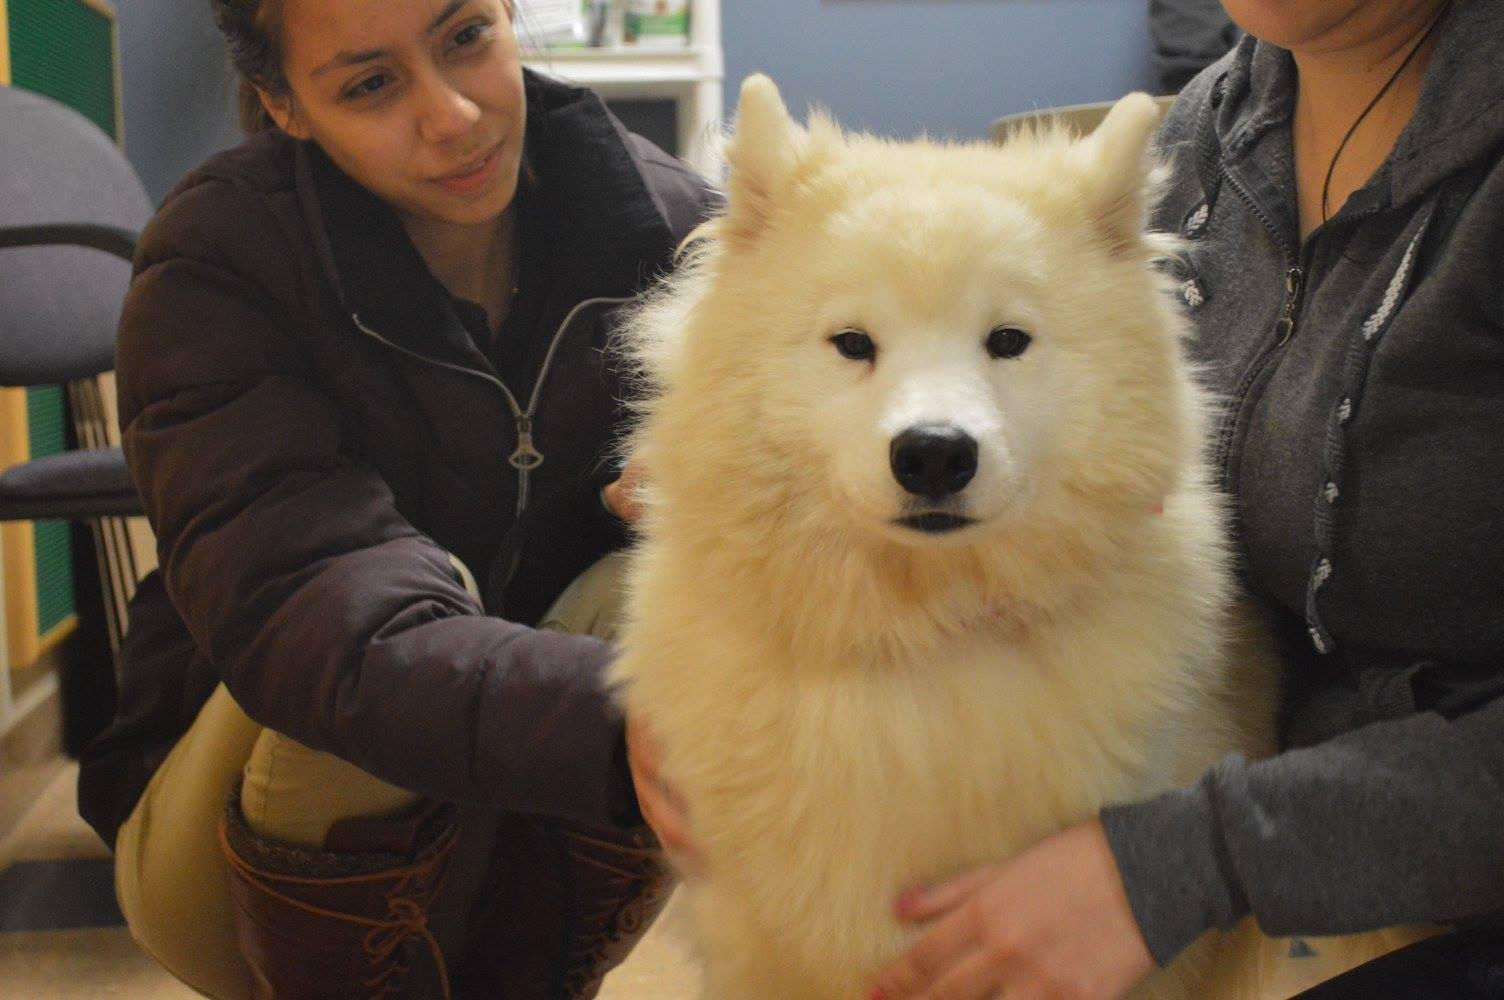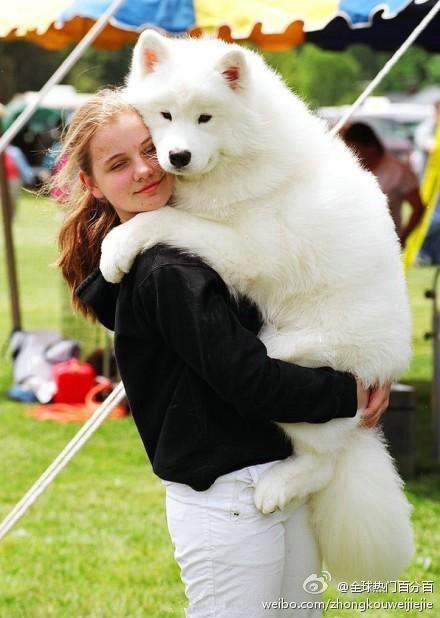The first image is the image on the left, the second image is the image on the right. Examine the images to the left and right. Is the description "A white dog is wearing an orange and black Halloween costume that has a matching hat." accurate? Answer yes or no. No. The first image is the image on the left, the second image is the image on the right. Considering the images on both sides, is "at least one dog is dressed in costume" valid? Answer yes or no. No. 